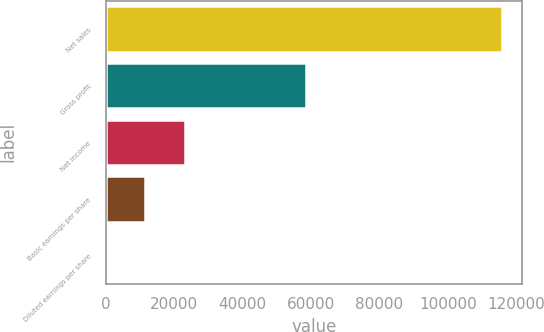<chart> <loc_0><loc_0><loc_500><loc_500><bar_chart><fcel>Net sales<fcel>Gross profit<fcel>Net income<fcel>Basic earnings per share<fcel>Diluted earnings per share<nl><fcel>115892<fcel>58463<fcel>23178.7<fcel>11589.5<fcel>0.32<nl></chart> 